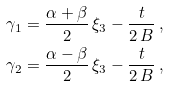Convert formula to latex. <formula><loc_0><loc_0><loc_500><loc_500>\gamma _ { 1 } & = \frac { \alpha + \beta } { 2 } \, \xi _ { 3 } - \frac { t } { 2 \, B } \, , \\ \gamma _ { 2 } & = \frac { \alpha - \beta } { 2 } \, \xi _ { 3 } - \frac { t } { 2 \, B } \, ,</formula> 